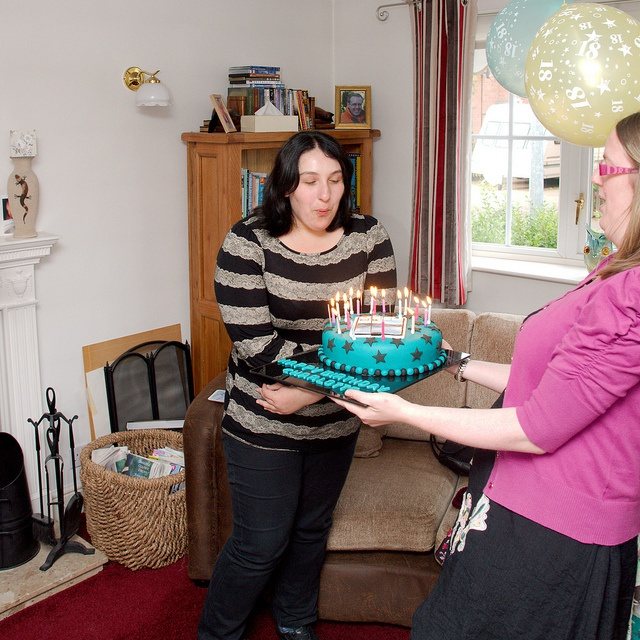Describe the objects in this image and their specific colors. I can see people in lightgray, violet, black, and lightpink tones, people in lightgray, black, darkgray, tan, and gray tones, couch in lightgray, maroon, gray, and black tones, cake in lightgray, white, teal, turquoise, and lightpink tones, and handbag in lightgray, black, maroon, brown, and gray tones in this image. 